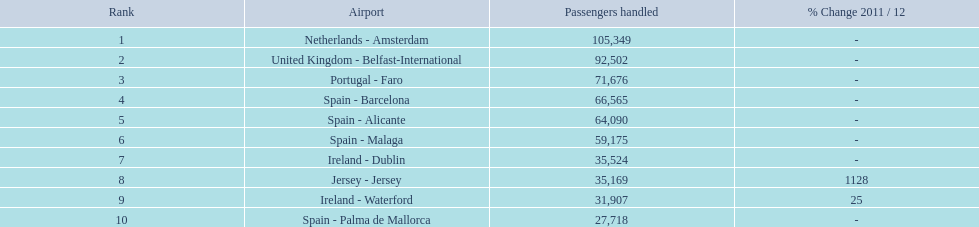What are the 10 busiest routes to and from london southend airport? Netherlands - Amsterdam, United Kingdom - Belfast-International, Portugal - Faro, Spain - Barcelona, Spain - Alicante, Spain - Malaga, Ireland - Dublin, Jersey - Jersey, Ireland - Waterford, Spain - Palma de Mallorca. Of these, which airport is in portugal? Portugal - Faro. Which air terminals are located in europe? Netherlands - Amsterdam, United Kingdom - Belfast-International, Portugal - Faro, Spain - Barcelona, Spain - Alicante, Spain - Malaga, Ireland - Dublin, Ireland - Waterford, Spain - Palma de Mallorca. Which one is from portugal? Portugal - Faro. 